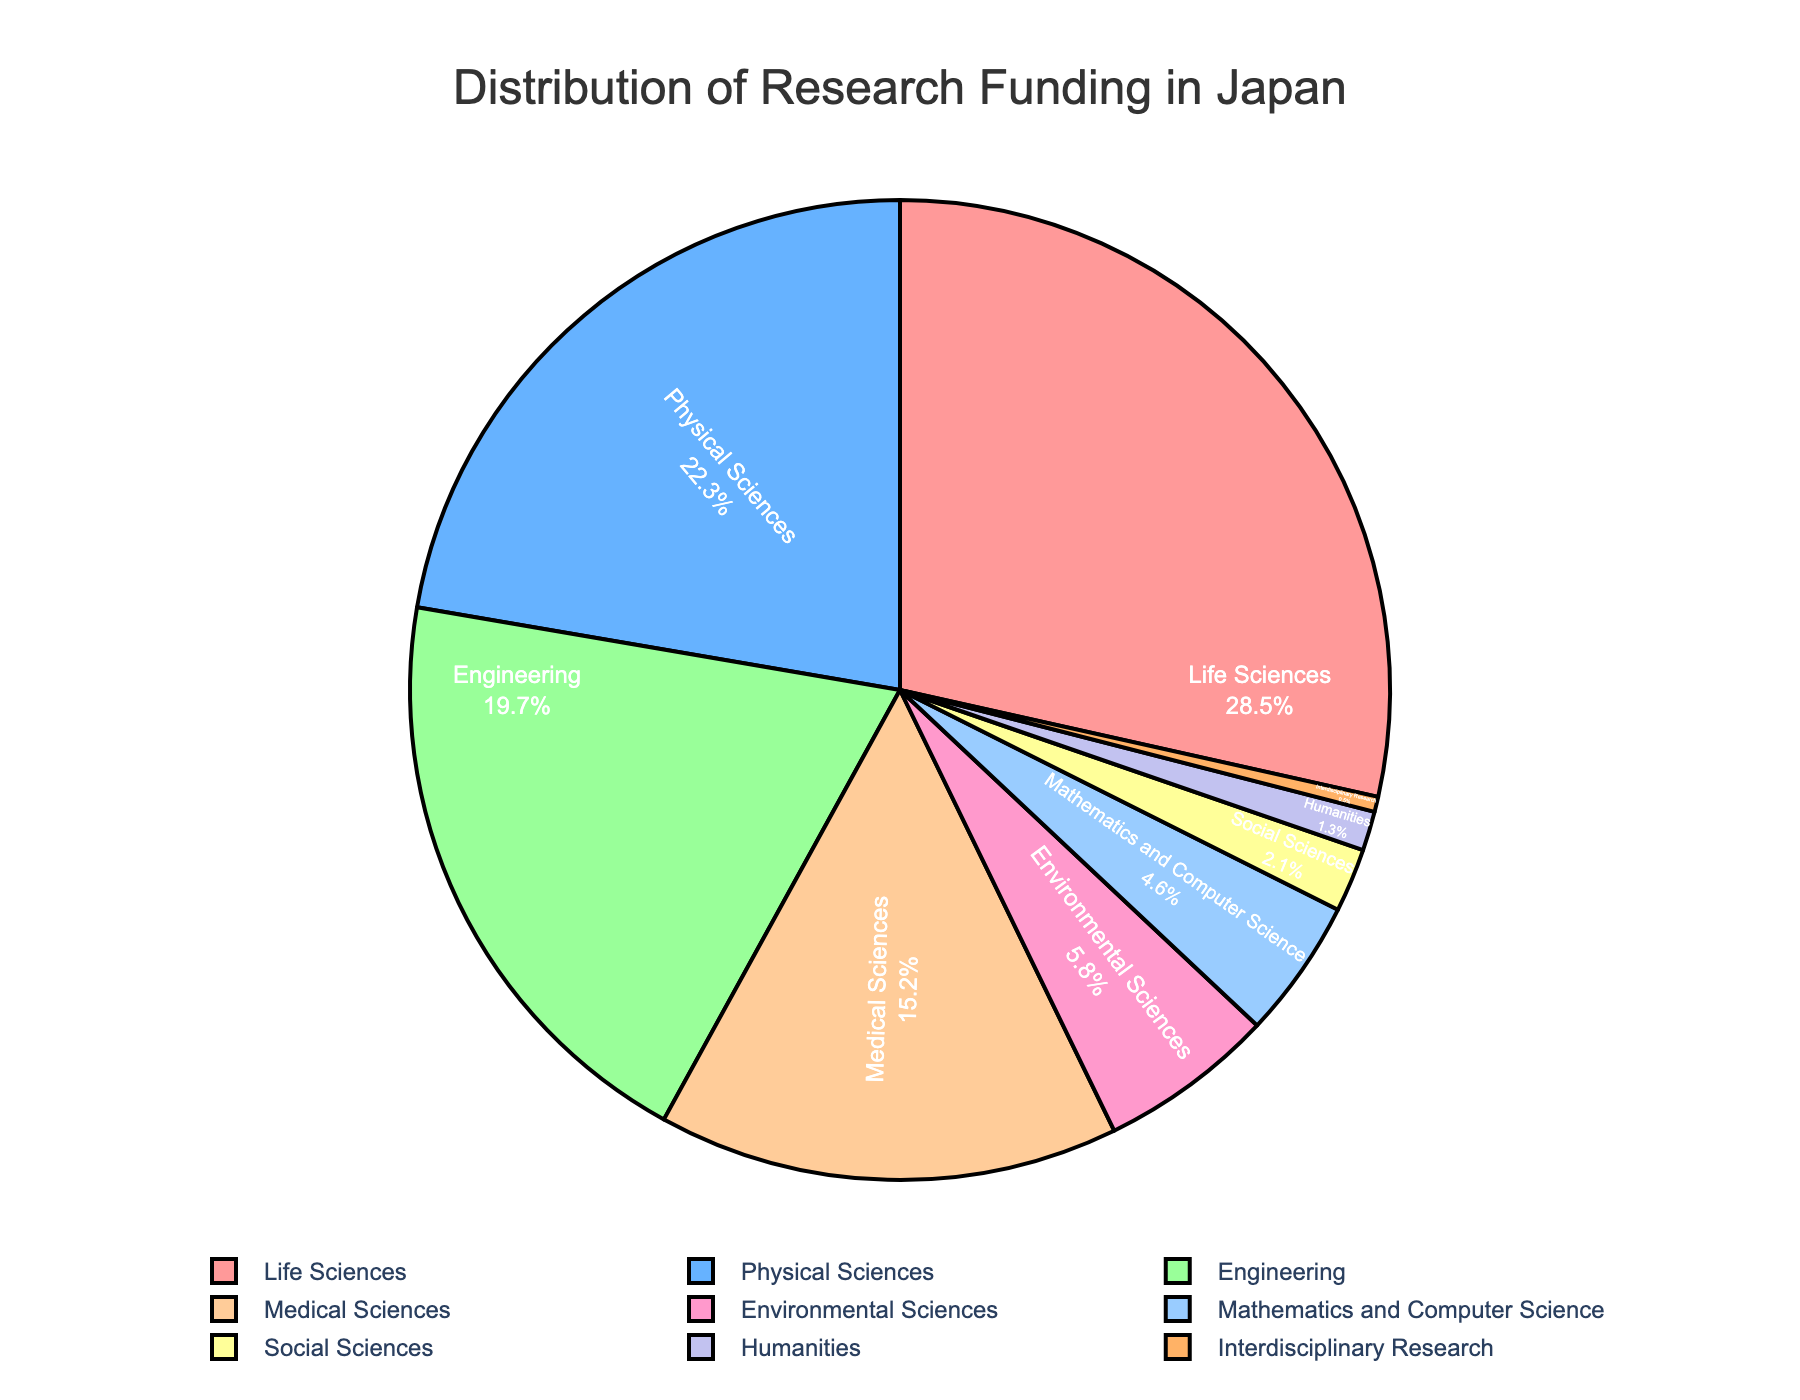Which discipline receives the highest percentage of research funding? The discipline with the highest percentage slice on the pie chart corresponds to where the largest funding allocation is located, and it's colored differently.
Answer: Life Sciences Which two disciplines combined receive more than 50% of the total research funding? By visually adding the percentages: Life Sciences (28.5%) + Physical Sciences (22.3%) = 50.8%, which is more than half of the total funding.
Answer: Life Sciences and Physical Sciences How much more funding does the Medical Sciences discipline receive compared to the Humanities discipline? Identify the funding percentages for Medical Sciences (15.2%) and Humanities (1.3%) and subtract the smaller from the larger: 15.2% - 1.3% = 13.9%.
Answer: 13.9% Which discipline has the lowest funding and what percentage does it have? The smallest slice in the pie chart represents the discipline with the least funding, which is marked and labeled accordingly.
Answer: Interdisciplinary Research with 0.5% How does the funding for Engineering compare to that for Environmental Sciences? Locate and compare the percentage slices for Engineering (19.7%) and Environmental Sciences (5.8%) in the pie chart.
Answer: Engineering has more funding than Environmental Sciences What is the sum of the funding percentages for disciplines that receive less than 5% each? Identify all disciplines with less than 5% (Mathematics and Computer Science: 4.6%, Social Sciences: 2.1%, Humanities: 1.3%, Interdisciplinary Research: 0.5%) and add their percentages: 4.6% + 2.1% + 1.3% + 0.5% = 8.5%.
Answer: 8.5% What is the average funding percentage for the three disciplines with the highest funding? Identify the top three funded disciplines (Life Sciences: 28.5%, Physical Sciences: 22.3%, Engineering: 19.7%) and compute their average: (28.5% + 22.3% + 19.7%) / 3 ≈ 23.5%.
Answer: 23.5% Which segment is colored blue, and what is its funding percentage? Visually identify the pie chart slice colored blue, which corresponds to a specific discipline labeled with its funding percentage.
Answer: Physical Sciences with 22.3% How does the combined funding for Social Sciences and Humanities compare to the funding for Environmental Sciences? Add the percentages for Social Sciences (2.1%) and Humanities (1.3%) and compare it to Environmental Sciences (5.8%): 2.1% + 1.3% = 3.4%, which is less than 5.8%.
Answer: Environmental Sciences has more funding If the funding percentages for Life Sciences and Physical Sciences were swapped, which discipline would then receive the highest funding? Swapping the percentages makes Physical Sciences have 28.5% and Life Sciences 22.3%. The discipline with 28.5% would then be Physical Sciences.
Answer: Physical Sciences 